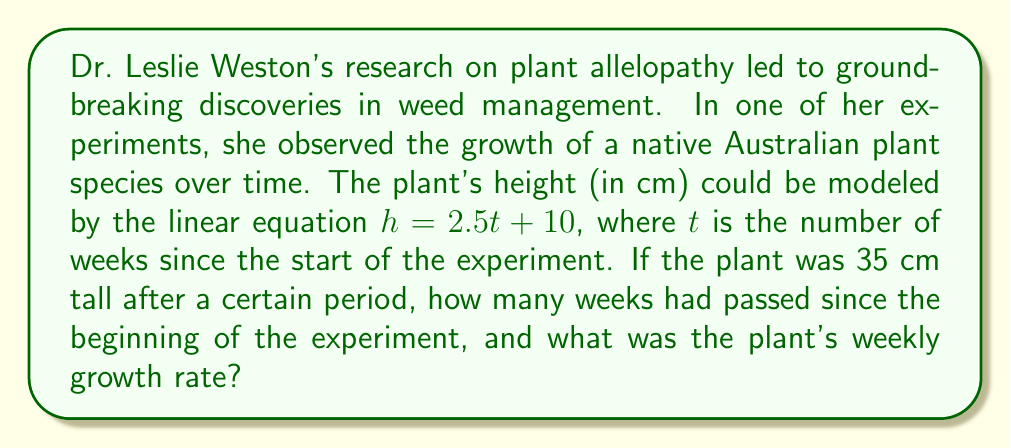Teach me how to tackle this problem. Let's approach this step-by-step:

1) We're given the linear equation $h = 2.5t + 10$, where:
   $h$ = height of the plant in cm
   $t$ = time in weeks
   $2.5$ = slope of the line (growth rate)
   $10$ = y-intercept (initial height)

2) We know that at some point, the plant's height ($h$) was 35 cm. Let's substitute this into our equation:

   $35 = 2.5t + 10$

3) To solve for $t$, we first subtract 10 from both sides:

   $35 - 10 = 2.5t + 10 - 10$
   $25 = 2.5t$

4) Now, divide both sides by 2.5:

   $\frac{25}{2.5} = \frac{2.5t}{2.5}$
   $10 = t$

5) Therefore, 10 weeks had passed when the plant reached 35 cm.

6) The plant's weekly growth rate is represented by the slope of the line, which is 2.5 cm per week.

This linear model allows us to predict the plant's height at any given time and understand its consistent growth rate, which is crucial in plant biology studies.
Answer: 10 weeks had passed, and the plant's growth rate was 2.5 cm per week. 